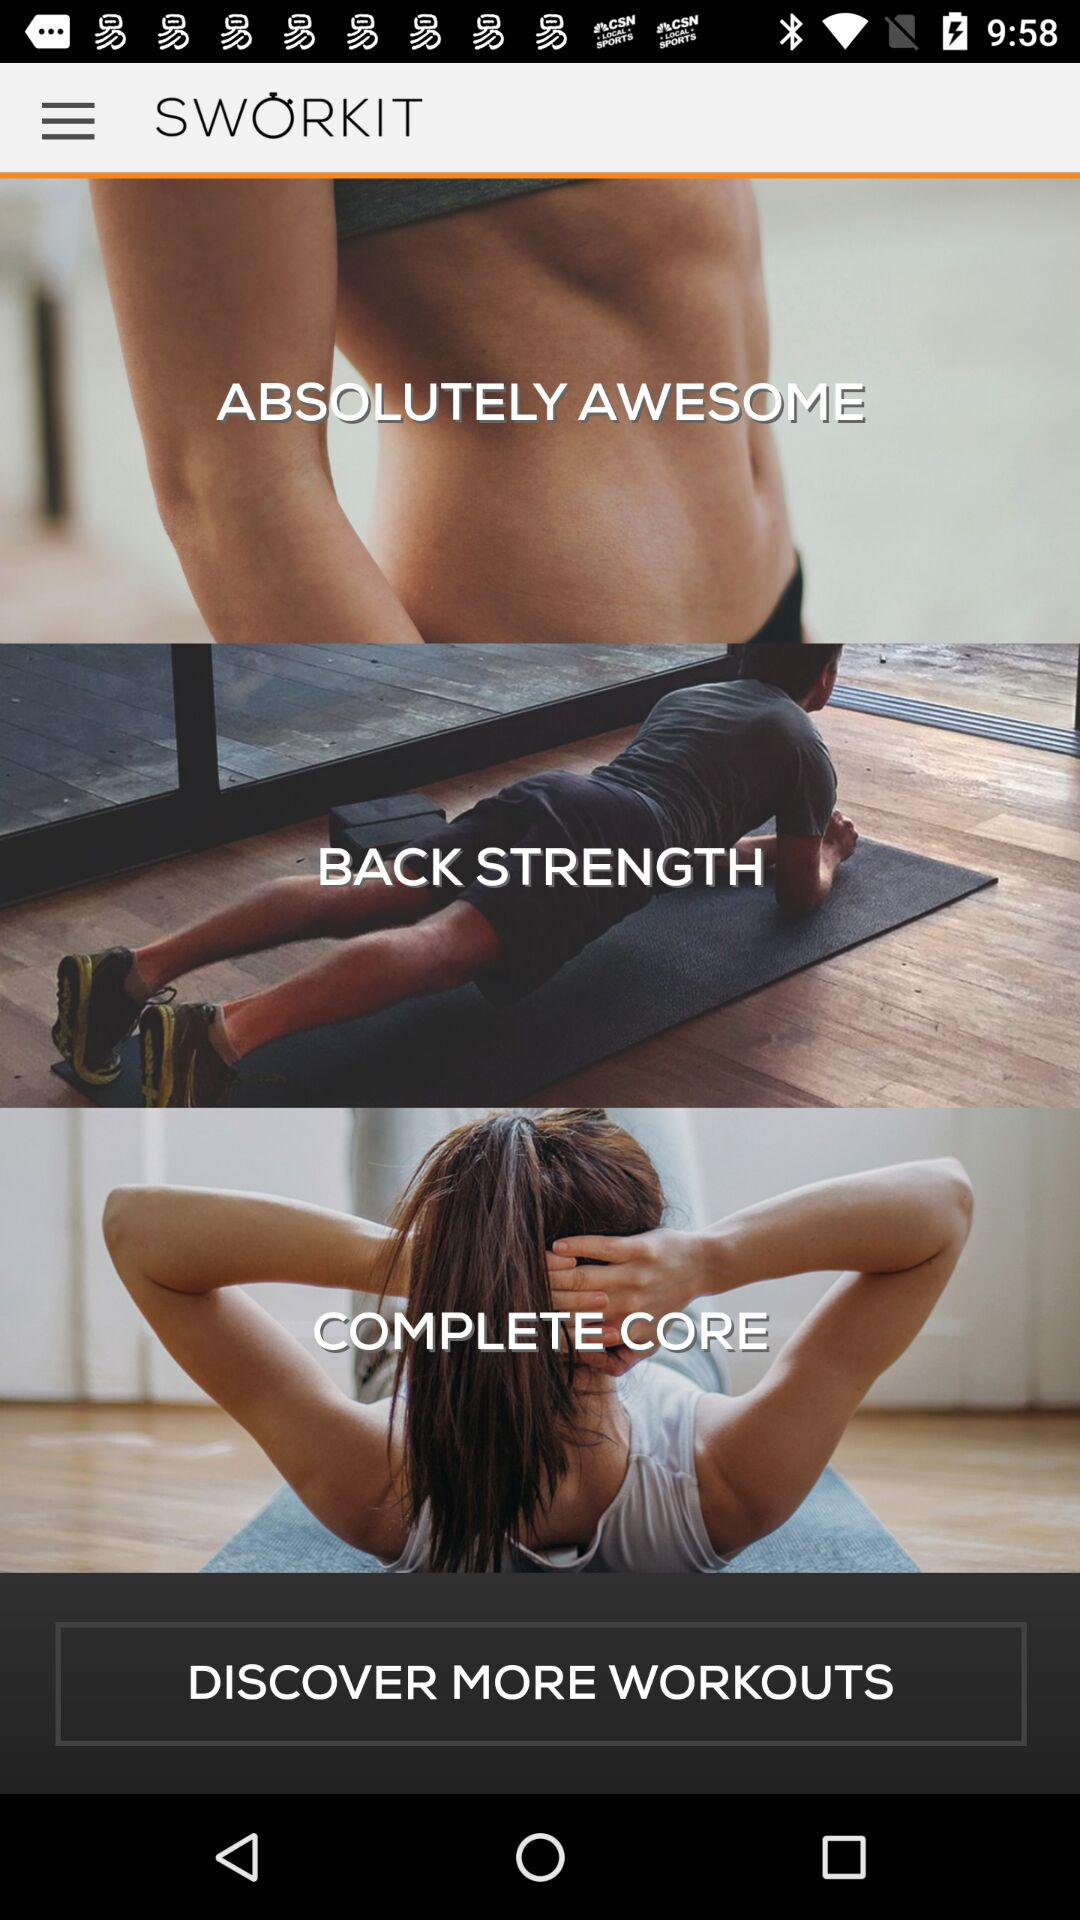What is the name of the application? The name of the application is "SWORKIT". 